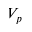<formula> <loc_0><loc_0><loc_500><loc_500>V _ { p }</formula> 